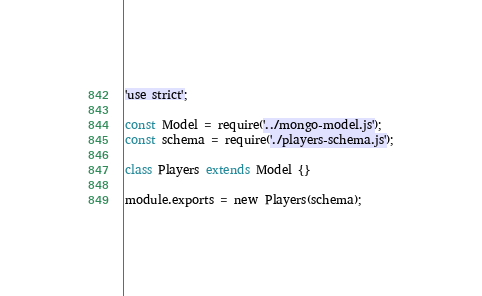<code> <loc_0><loc_0><loc_500><loc_500><_JavaScript_>'use strict';

const Model = require('../mongo-model.js');
const schema = require('./players-schema.js');

class Players extends Model {}

module.exports = new Players(schema);

</code> 